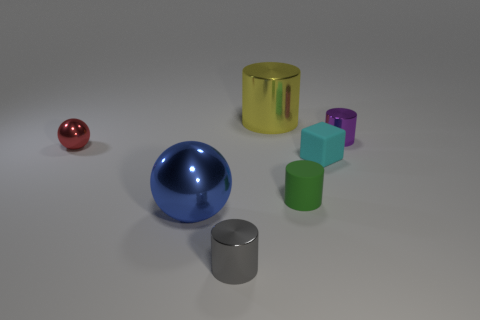There is a big thing that is on the left side of the big shiny cylinder; does it have the same color as the tiny rubber object in front of the cyan rubber thing?
Make the answer very short. No. What shape is the shiny thing behind the metal thing that is to the right of the large yellow metallic cylinder?
Make the answer very short. Cylinder. What number of other things are the same color as the large ball?
Offer a very short reply. 0. Is the material of the cylinder that is to the right of the tiny green matte thing the same as the thing behind the purple thing?
Provide a short and direct response. Yes. There is a rubber object in front of the cube; what size is it?
Ensure brevity in your answer.  Small. There is a small gray thing that is the same shape as the tiny purple object; what is its material?
Ensure brevity in your answer.  Metal. Are there any other things that have the same size as the purple metallic cylinder?
Ensure brevity in your answer.  Yes. What is the shape of the big thing behind the blue shiny sphere?
Make the answer very short. Cylinder. What number of purple rubber things have the same shape as the gray metal object?
Provide a short and direct response. 0. Is the number of small purple metallic cylinders that are to the left of the big ball the same as the number of tiny cyan objects to the right of the cyan rubber thing?
Provide a short and direct response. Yes. 